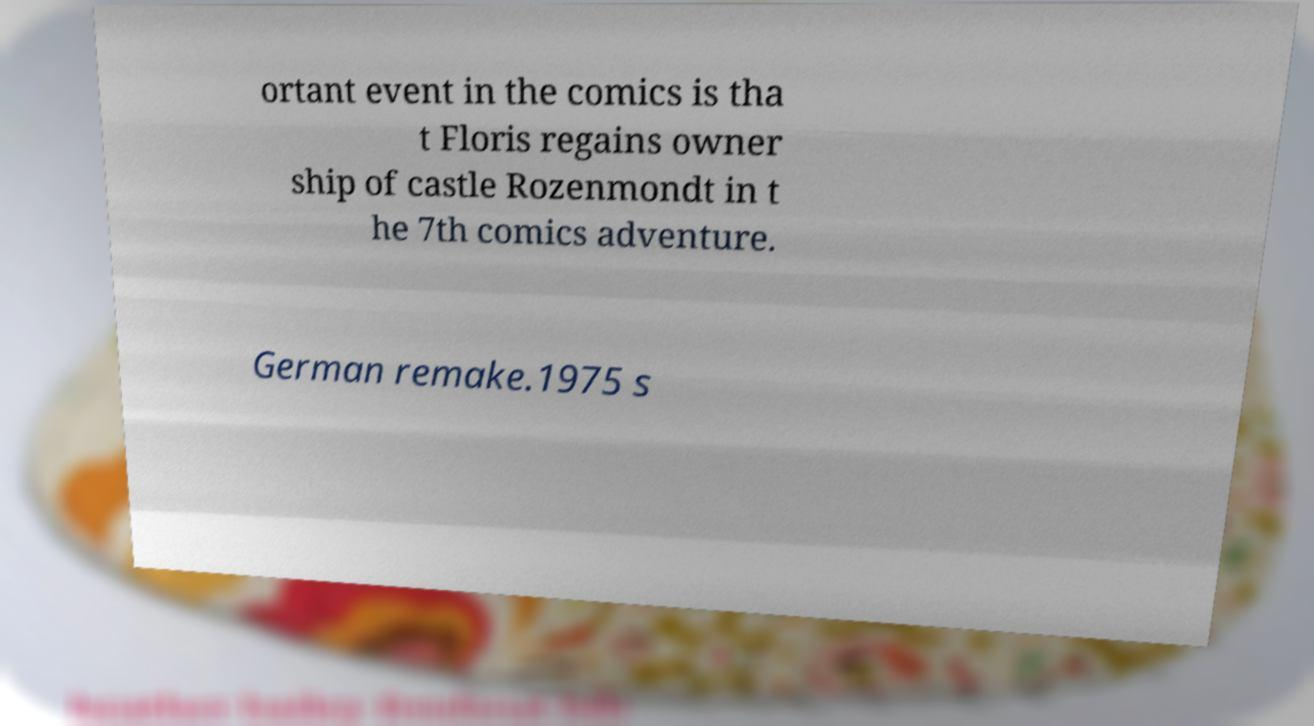There's text embedded in this image that I need extracted. Can you transcribe it verbatim? ortant event in the comics is tha t Floris regains owner ship of castle Rozenmondt in t he 7th comics adventure. German remake.1975 s 